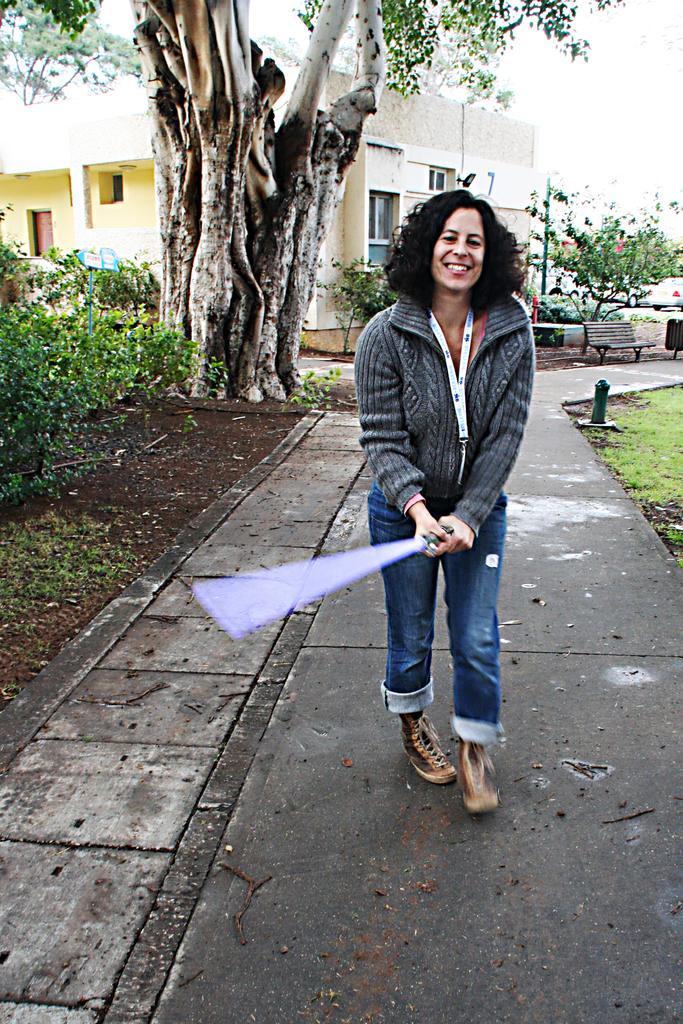Could you give a brief overview of what you see in this image? In this image we can see a woman is holding something in her hands and walking on the road. Here we can see plants, grass, wooden bench, trees, house and the sky in the background. 